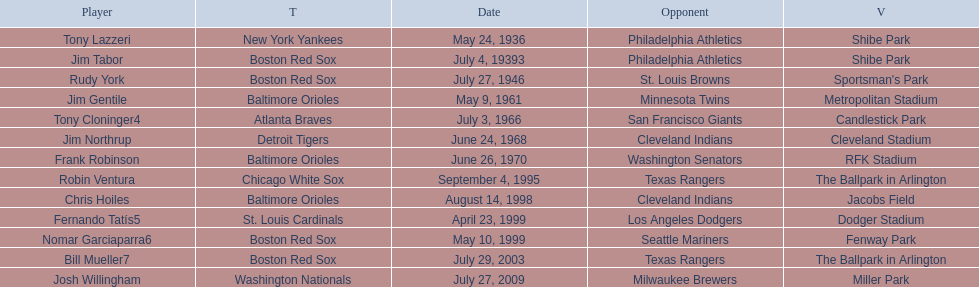What is the number of times a boston red sox player has had two grand slams in one game? 4. 